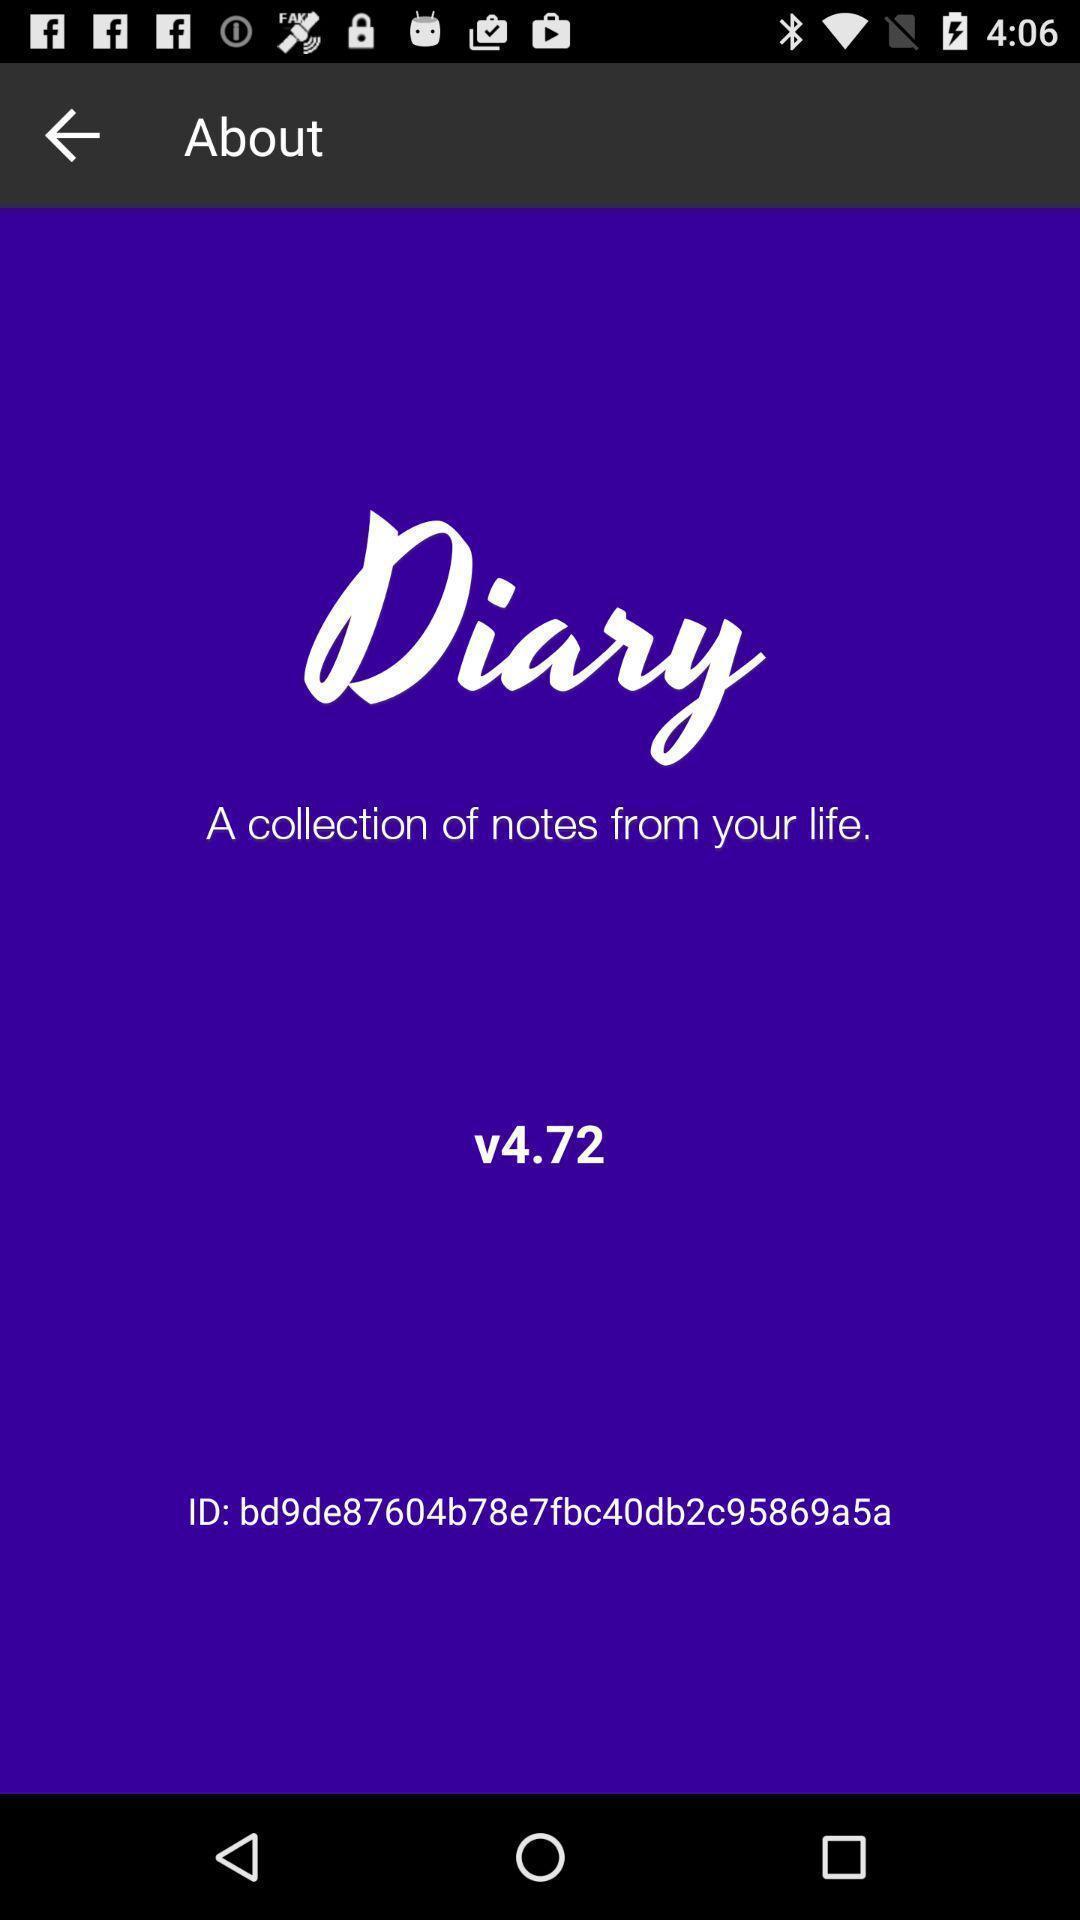What is the overall content of this screenshot? Screen showing the welcome page of an social app. 